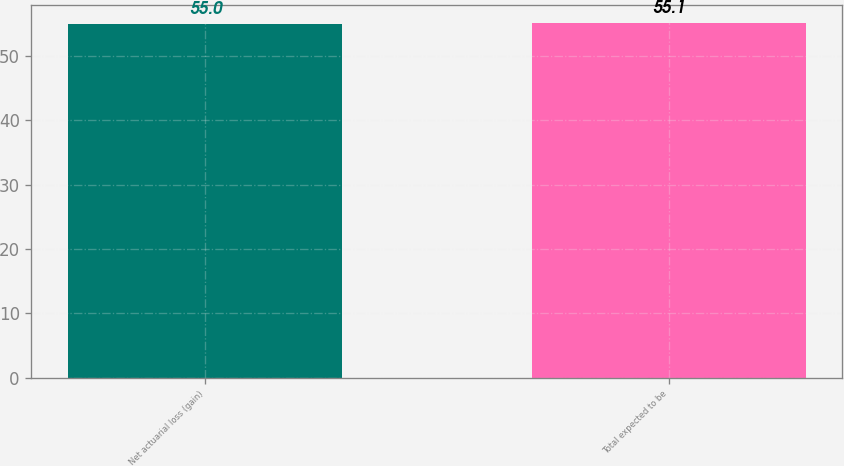Convert chart. <chart><loc_0><loc_0><loc_500><loc_500><bar_chart><fcel>Net actuarial loss (gain)<fcel>Total expected to be<nl><fcel>55<fcel>55.1<nl></chart> 